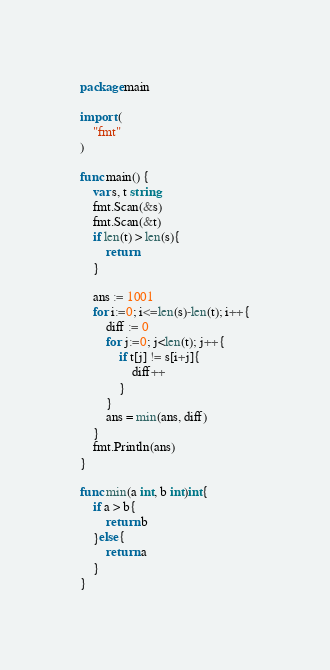<code> <loc_0><loc_0><loc_500><loc_500><_Go_>package main

import (
	"fmt"
)

func main() {
	var s, t string
	fmt.Scan(&s)
	fmt.Scan(&t)
	if len(t) > len(s){
		return
	}

	ans := 1001
	for i:=0; i<=len(s)-len(t); i++{
		diff := 0
		for j:=0; j<len(t); j++{
			if t[j] != s[i+j]{
				diff++
			}
		}
		ans = min(ans, diff)
	}
	fmt.Println(ans)
}

func min(a int, b int)int{
	if a > b{
		return b
	}else{
		return a
	}
}</code> 